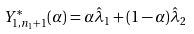<formula> <loc_0><loc_0><loc_500><loc_500>Y _ { 1 , n _ { 1 } + 1 } ^ { * } ( \alpha ) = \alpha \hat { \lambda } _ { 1 } + ( 1 - \alpha ) \hat { \lambda } _ { 2 }</formula> 